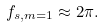Convert formula to latex. <formula><loc_0><loc_0><loc_500><loc_500>f _ { s , m = 1 } \approx 2 \pi .</formula> 